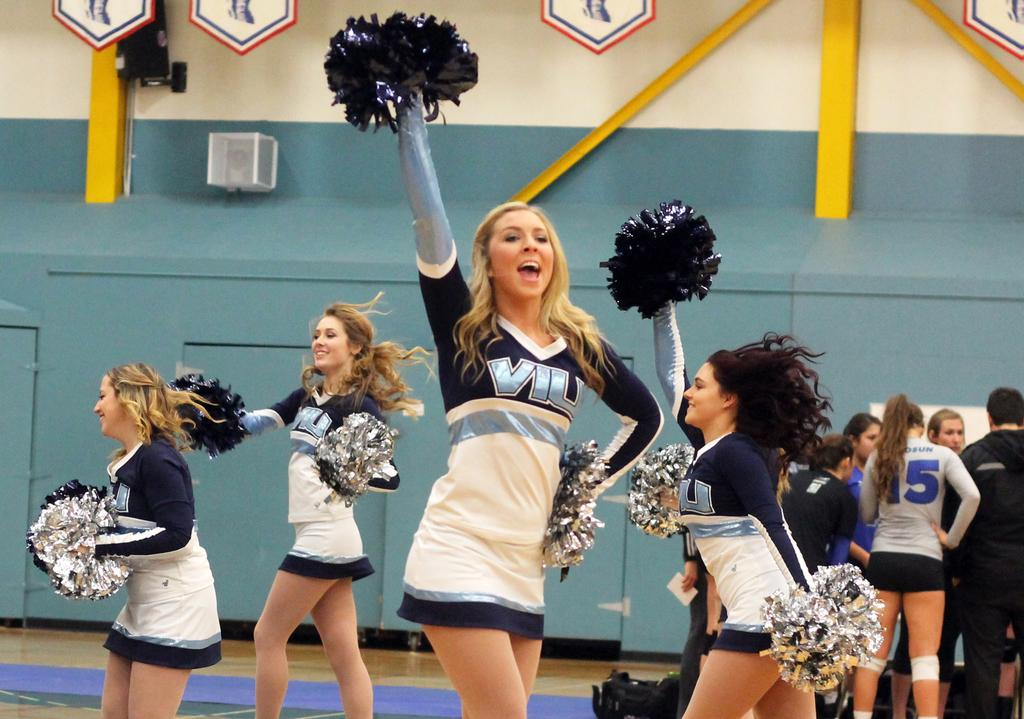<image>
Create a compact narrative representing the image presented. Cheerleaders are cheering wearing Vil on their shirts 